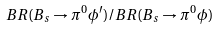Convert formula to latex. <formula><loc_0><loc_0><loc_500><loc_500>B R ( B _ { s } \rightarrow \pi ^ { 0 } \phi ^ { \prime } ) / B R ( B _ { s } \rightarrow \pi ^ { 0 } \phi )</formula> 